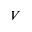Convert formula to latex. <formula><loc_0><loc_0><loc_500><loc_500>V</formula> 